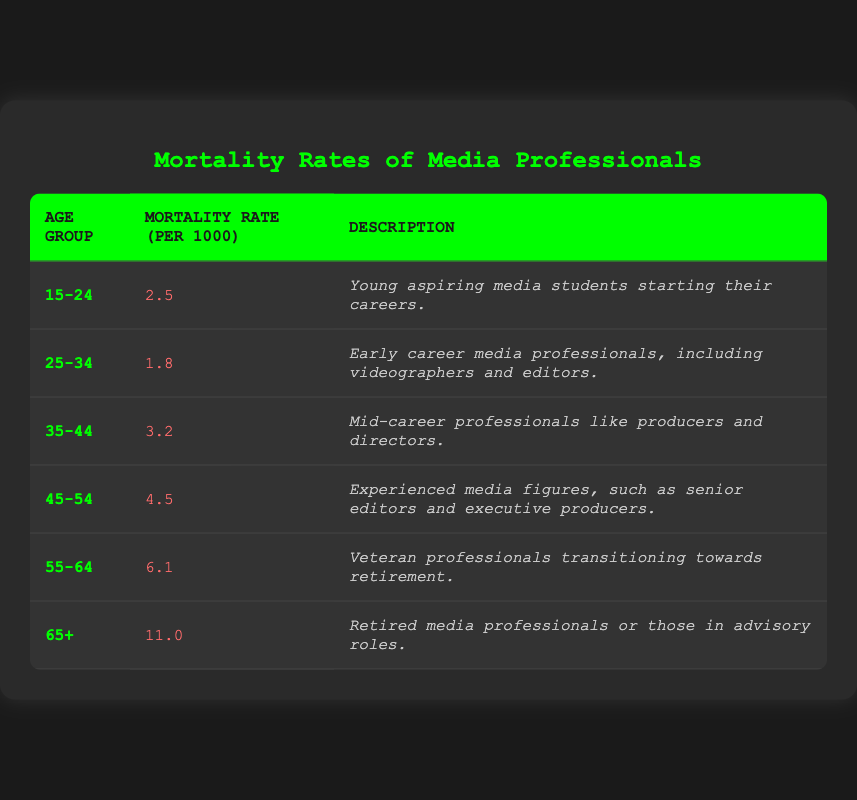What is the mortality rate for the age group 45-54? The table lists the mortality rate for the age group 45-54 as 4.5 per 1000.
Answer: 4.5 Which age group has the highest mortality rate? The highest mortality rate of 11.0 per 1000 is found in the age group 65 and older.
Answer: 65+ What is the total mortality rate for the age groups 15-24 and 25-34 combined? To find the total, add the mortality rates: 2.5 (15-24) + 1.8 (25-34) = 4.3.
Answer: 4.3 Is the mortality rate for age group 35-44 more than for age group 25-34? The mortality rate for age group 35-44 is 3.2, which is greater than 1.8 for age group 25-34. Therefore, the statement is true.
Answer: Yes What is the average mortality rate of all age groups listed in the table? To find the average, sum all the mortality rates: 2.5 + 1.8 + 3.2 + 4.5 + 6.1 + 11.0 = 29.1. Then, divide by the number of age groups (6): 29.1 / 6 = 4.85.
Answer: 4.85 For which age group does the description mention "veteran professionals transitioning towards retirement"? The age group 55-64 is described as featuring veteran professionals transitioning towards retirement.
Answer: 55-64 What is the difference in mortality rates between the age groups 45-54 and 55-64? The mortality rate for age group 45-54 is 4.5 and for 55-64 is 6.1. The difference is 6.1 - 4.5 = 1.6.
Answer: 1.6 Does the age group 25-34 have a higher mortality rate than 15-24? The mortality rate for age group 25-34 is 1.8, which is lower than 2.5 for age group 15-24. Therefore, the statement is false.
Answer: No What description applies to the age group with the lowest mortality rate? The age group 25-34 has the lowest rate of 1.8, and it is described as early career media professionals.
Answer: Early career media professionals 